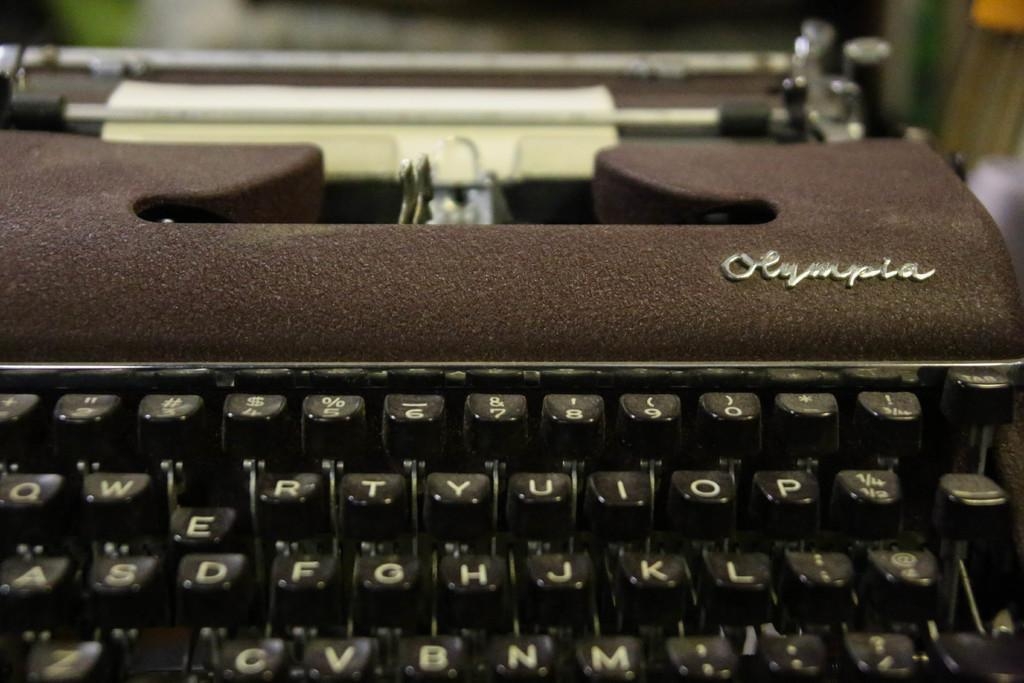<image>
Create a compact narrative representing the image presented. the word Olympia that is on the typewriter 